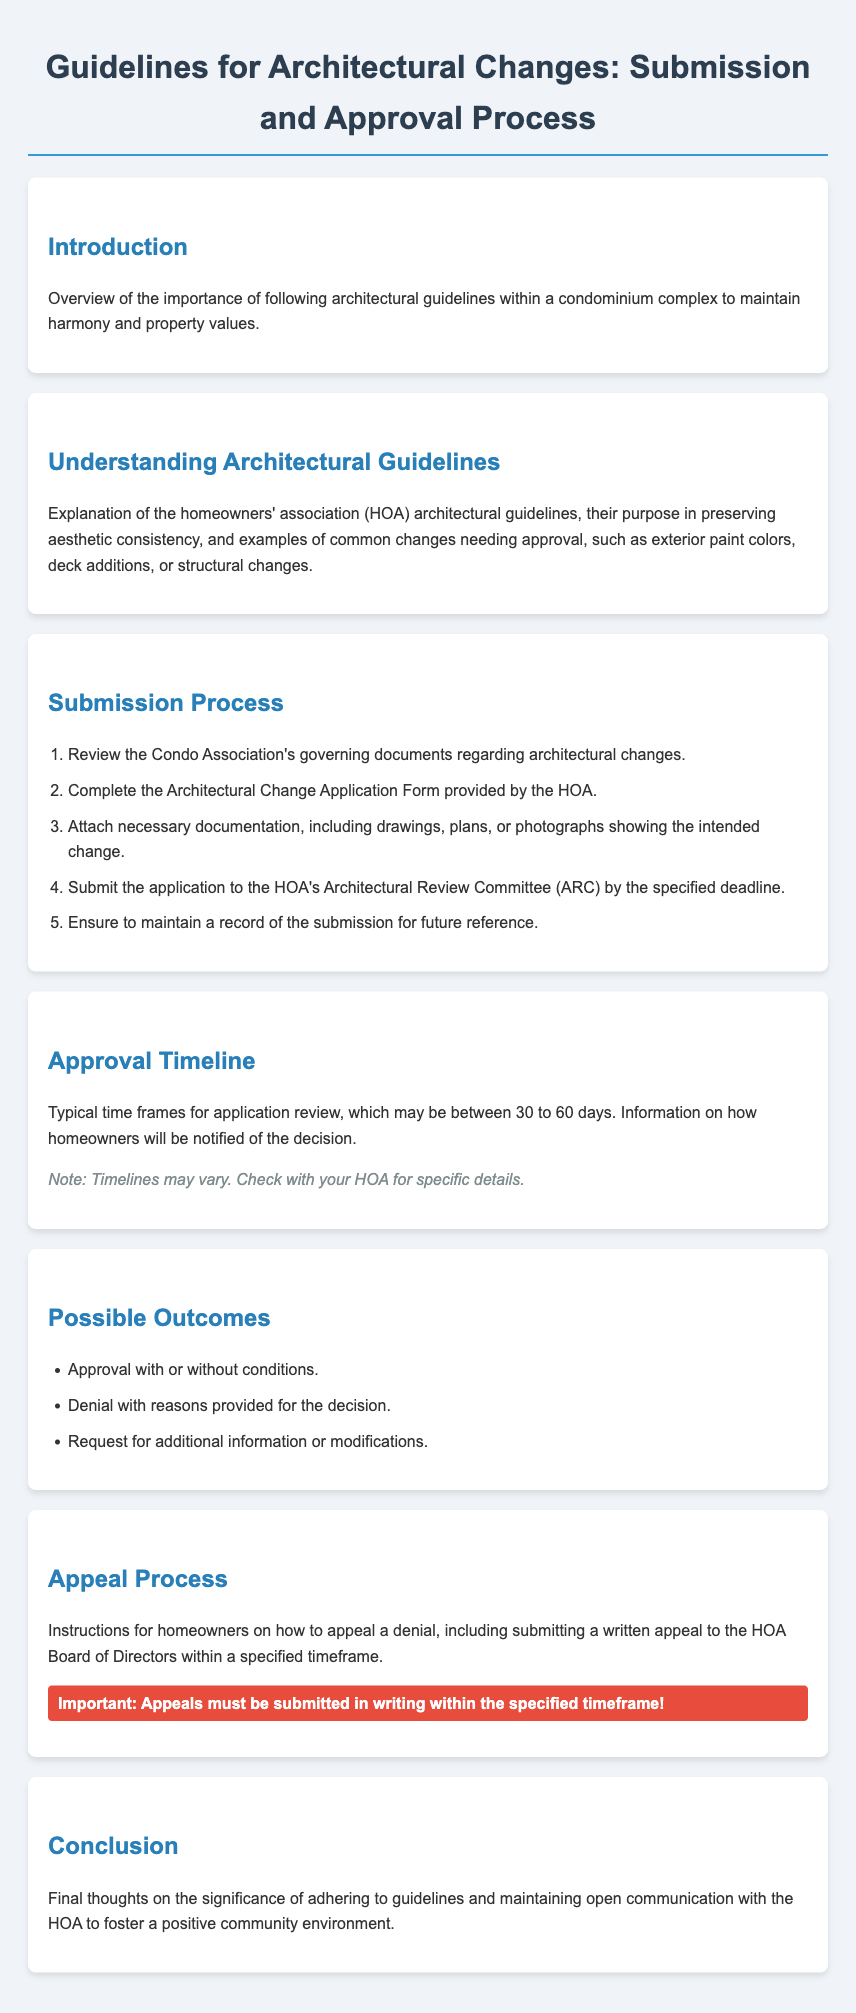What is the typical approval timeline for applications? The document states that typical time frames for application review may be between 30 to 60 days.
Answer: 30 to 60 days What must be attached to the Architectural Change Application Form? Necessary documentation includes drawings, plans, or photographs showing the intended change.
Answer: Drawings, plans, or photographs What is the first step in the submission process? The first step involves reviewing the Condo Association's governing documents regarding architectural changes.
Answer: Review governing documents What are the possible outcomes of an application? The document lists approval with conditions, denial, and request for additional information as possible outcomes.
Answer: Approval, denial, request for additional information What should homeowners do if their application is denied? Homeowners should submit a written appeal to the HOA Board of Directors within a specified timeframe.
Answer: Submit a written appeal 